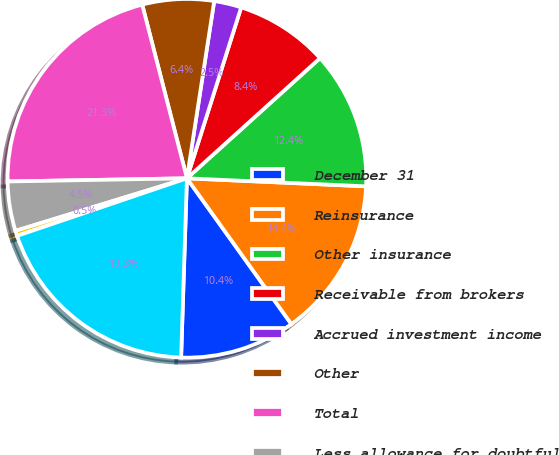Convert chart to OTSL. <chart><loc_0><loc_0><loc_500><loc_500><pie_chart><fcel>December 31<fcel>Reinsurance<fcel>Other insurance<fcel>Receivable from brokers<fcel>Accrued investment income<fcel>Other<fcel>Total<fcel>Less allowance for doubtful<fcel>allowance for other doubtful<fcel>Receivables<nl><fcel>10.41%<fcel>14.39%<fcel>12.4%<fcel>8.42%<fcel>2.46%<fcel>6.44%<fcel>21.27%<fcel>4.45%<fcel>0.47%<fcel>19.28%<nl></chart> 